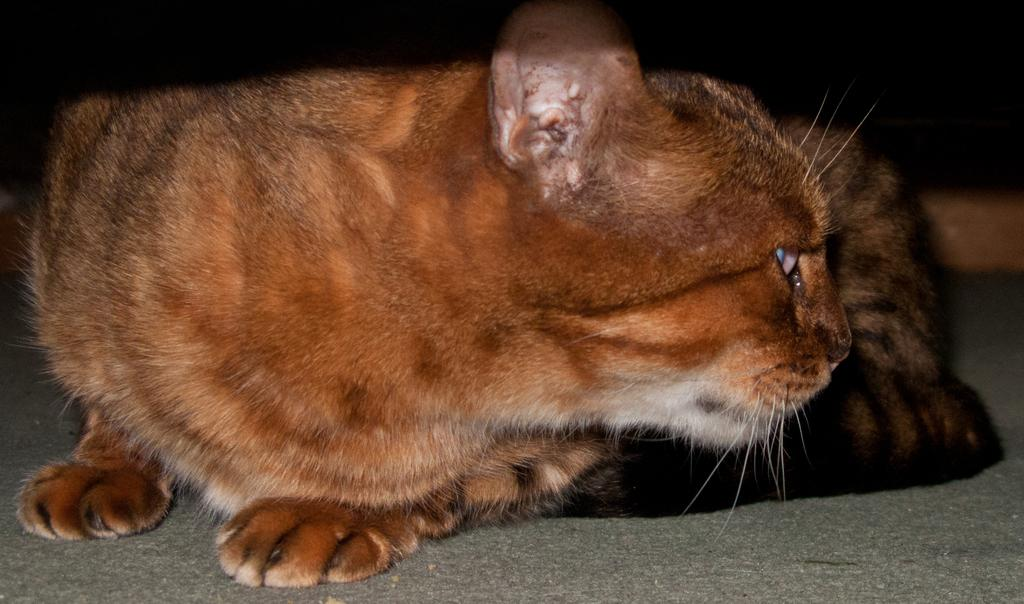What animal is present in the image? There is a cat in the image. What is the cat standing or sitting on? The cat is on a gray surface. What can be observed about the background of the image? The background of the image is dark in color. Can you describe the process the cat is going through in the image? There is no specific process being depicted in the image; the cat is simply present on a gray surface with a dark background. Is the cat swimming in the image? No, the cat is not swimming in the image; it is on a gray surface. 